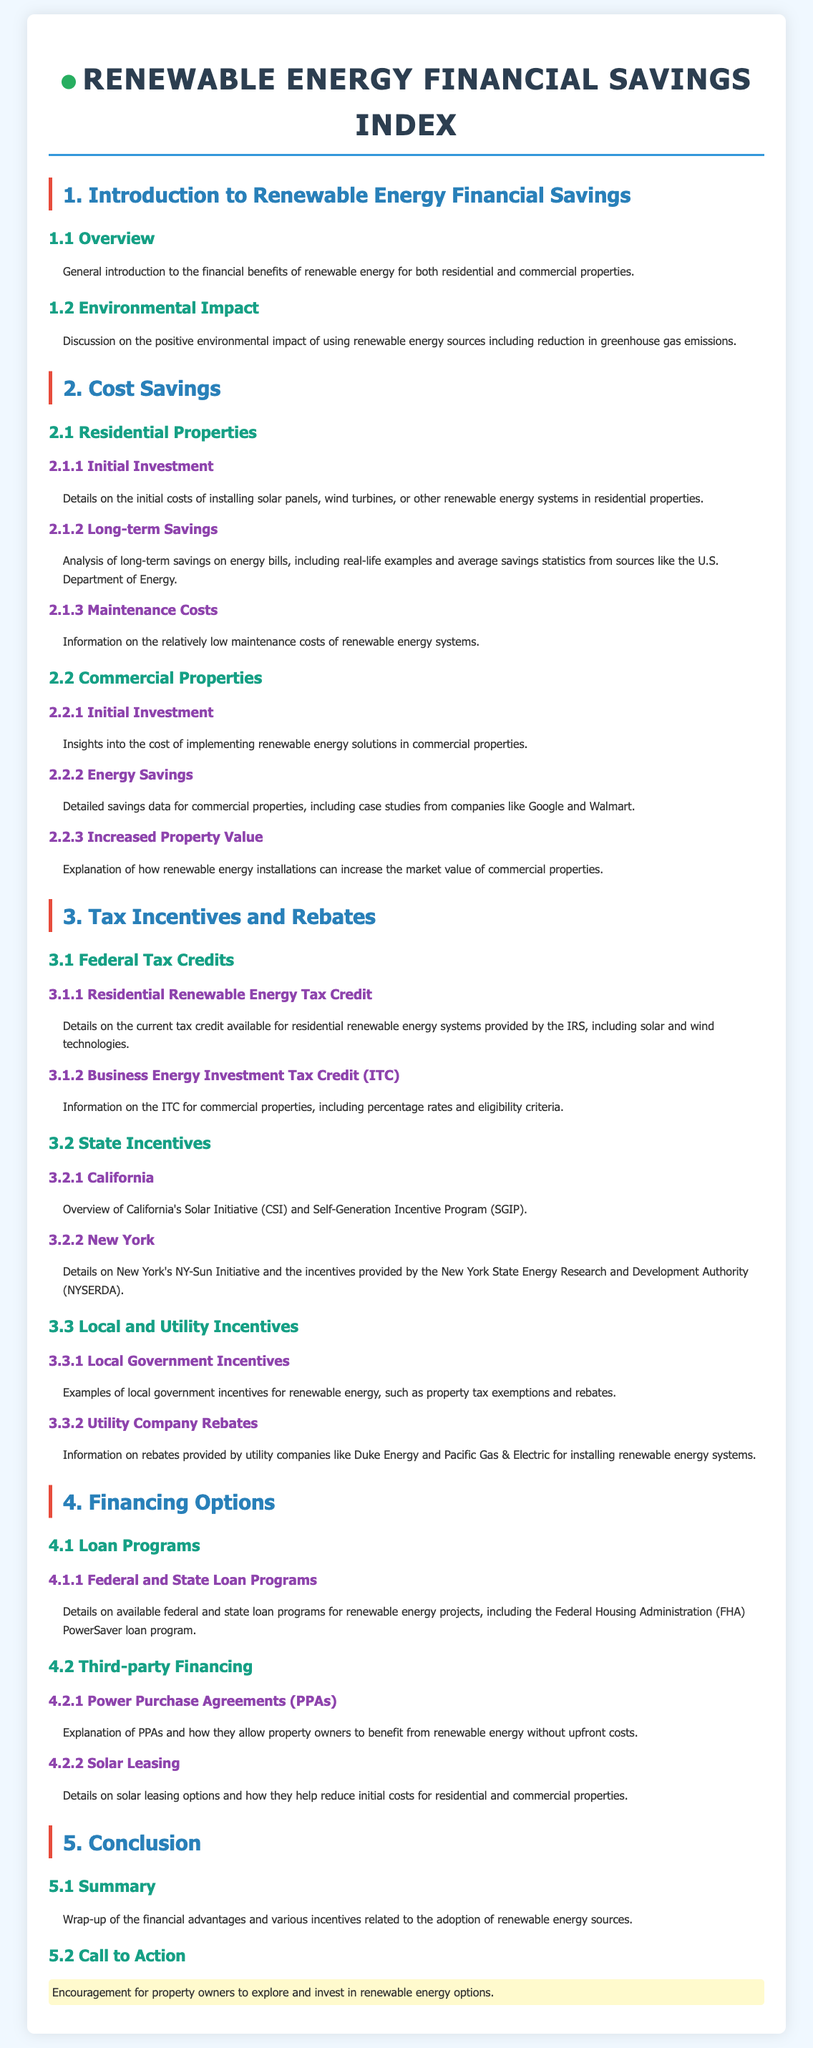What does "ITC" stand for? "ITC" refers to the "Business Energy Investment Tax Credit" mentioned in the section on tax incentives.
Answer: Business Energy Investment Tax Credit What is the main focus of section 2? Section 2 discusses "Cost Savings" for both residential and commercial properties utilizing renewable energy sources.
Answer: Cost Savings Which state is known for the Solar Initiative? The document highlights California for its Solar Initiative and Self-Generation Incentive Program.
Answer: California What is a key benefit of renewable energy systems discussed in the conclusion? The conclusion emphasizes the financial advantages and incentives related to adopting renewable energy sources.
Answer: Financial advantages How are property values affected by renewable energy installations? The document explains that renewable energy installations can increase the market value of commercial properties.
Answer: Increase the market value What program helps reduce initial costs for properties through leasing? "Solar Leasing" is mentioned in relation to helping reduce initial costs for both residential and commercial properties.
Answer: Solar Leasing What type of incentives might local governments offer? Local government incentives can include property tax exemptions and rebates for renewable energy installations.
Answer: Property tax exemptions and rebates What is a benefit of Power Purchase Agreements? PPAs allow property owners to benefit from renewable energy without upfront costs, as stated in the document.
Answer: Without upfront costs 